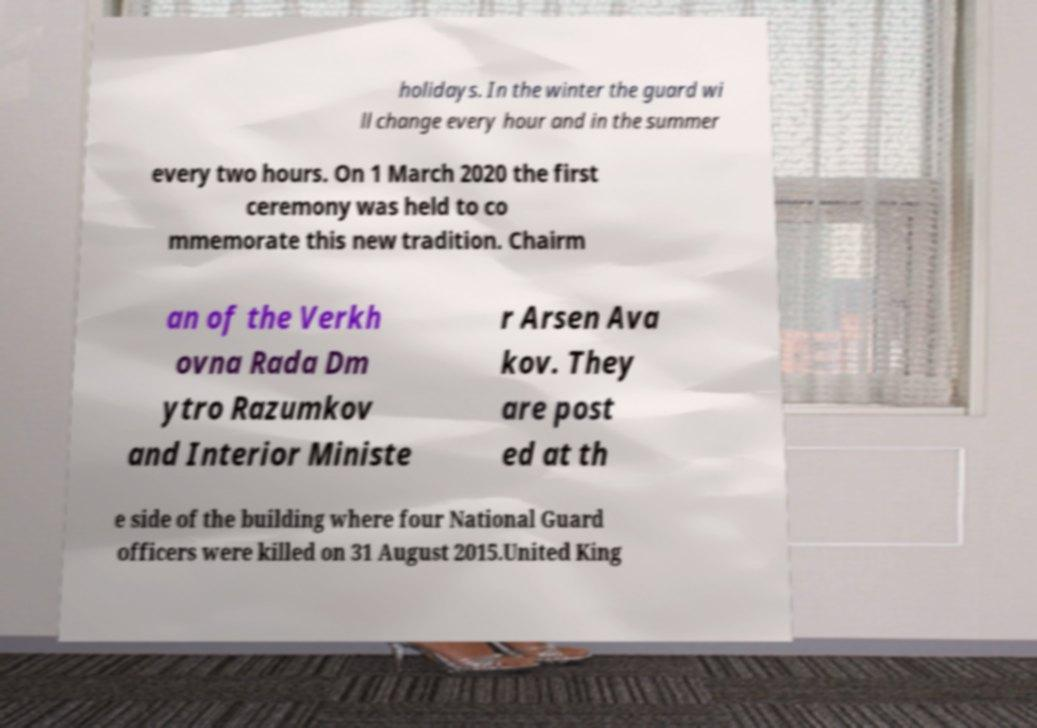There's text embedded in this image that I need extracted. Can you transcribe it verbatim? holidays. In the winter the guard wi ll change every hour and in the summer every two hours. On 1 March 2020 the first ceremony was held to co mmemorate this new tradition. Chairm an of the Verkh ovna Rada Dm ytro Razumkov and Interior Ministe r Arsen Ava kov. They are post ed at th e side of the building where four National Guard officers were killed on 31 August 2015.United King 